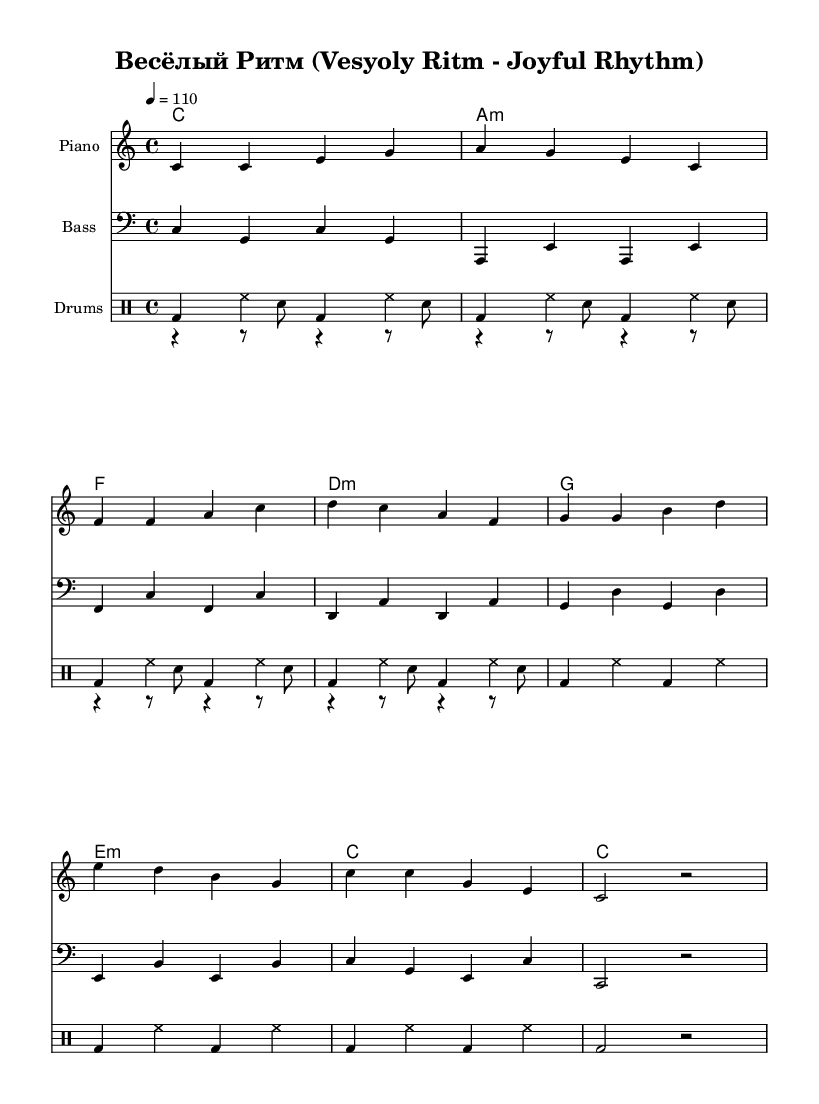What is the key signature of this music? The key signature shown is C major, which is indicated by the lack of flats or sharps in the key signature section.
Answer: C major What is the time signature of this piece? The time signature is indicated at the beginning of the music as 4/4, meaning there are four beats in each measure and the quarter note gets one beat.
Answer: 4/4 What is the tempo marking for this piece? The tempo marking is shown as "4 = 110," indicating that the quarter note should be played at a speed of 110 beats per minute.
Answer: 110 How many measures are there in the melody? By counting the grouped notes and the separations by vertical lines, there are a total of eight measures in the melody section.
Answer: 8 What rhythmic elements are present in the drum pattern? The drum pattern includes bass drum and hi-hat counts; the use of specific notations like 'bd' for bass drum and 'hh' for hi-hat indicates the rhythmic elements for funk music.
Answer: Bass drum and hi-hat Which language are the lyrics written in? The lyrics are presented in the text section and are clearly written in Russian, as indicated by the use of Cyrillic characters.
Answer: Russian Is this piece specifically designed for children? The context of the piece, including the lyrics, rhythm, and cheerful title "Весёлый Ритм," suggests it is specifically tailored for a children's audience, aiming to engage them through rhythm and fun.
Answer: Yes 